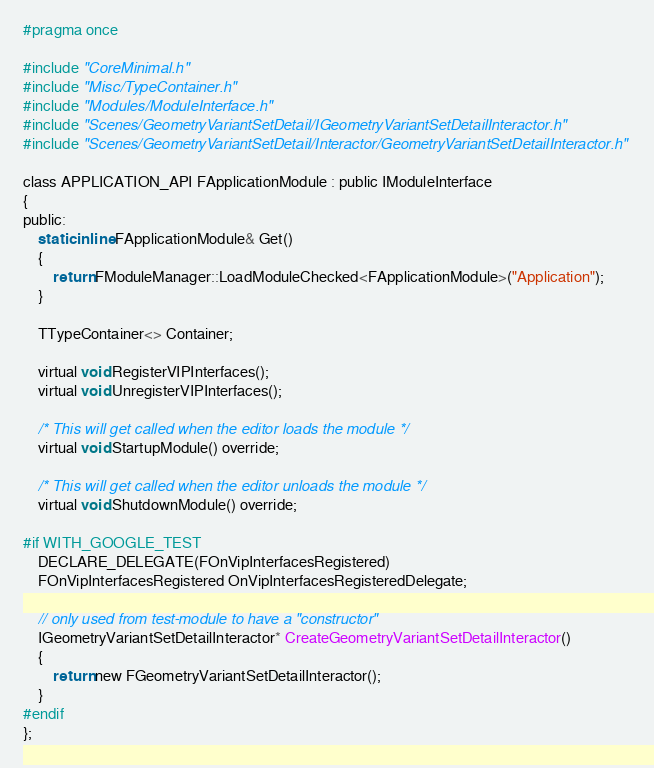<code> <loc_0><loc_0><loc_500><loc_500><_C_>#pragma once

#include "CoreMinimal.h"
#include "Misc/TypeContainer.h"
#include "Modules/ModuleInterface.h"
#include "Scenes/GeometryVariantSetDetail/IGeometryVariantSetDetailInteractor.h"
#include "Scenes/GeometryVariantSetDetail/Interactor/GeometryVariantSetDetailInteractor.h"

class APPLICATION_API FApplicationModule : public IModuleInterface
{
public:	
	static inline FApplicationModule& Get()
	{
		return FModuleManager::LoadModuleChecked<FApplicationModule>("Application");
	}

	TTypeContainer<> Container;

	virtual void RegisterVIPInterfaces();
	virtual void UnregisterVIPInterfaces();

	/* This will get called when the editor loads the module */
	virtual void StartupModule() override;

	/* This will get called when the editor unloads the module */
	virtual void ShutdownModule() override;

#if WITH_GOOGLE_TEST
	DECLARE_DELEGATE(FOnVipInterfacesRegistered)
	FOnVipInterfacesRegistered OnVipInterfacesRegisteredDelegate;

	// only used from test-module to have a "constructor"
	IGeometryVariantSetDetailInteractor* CreateGeometryVariantSetDetailInteractor()
	{
		return new FGeometryVariantSetDetailInteractor();
	}
#endif
};
</code> 